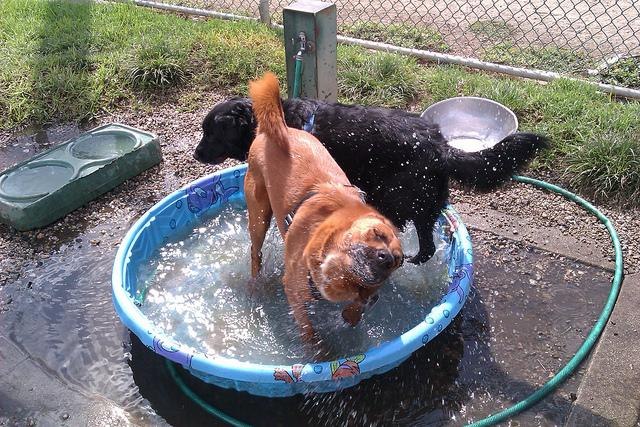What color is the garden hose wrapped around the kiddie pool? Please explain your reasoning. turquoise. The garden hose is turquoise colored. 